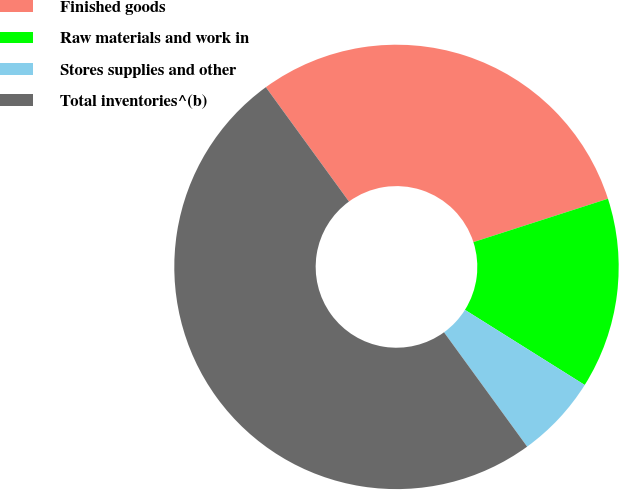<chart> <loc_0><loc_0><loc_500><loc_500><pie_chart><fcel>Finished goods<fcel>Raw materials and work in<fcel>Stores supplies and other<fcel>Total inventories^(b)<nl><fcel>30.04%<fcel>13.88%<fcel>6.08%<fcel>50.0%<nl></chart> 